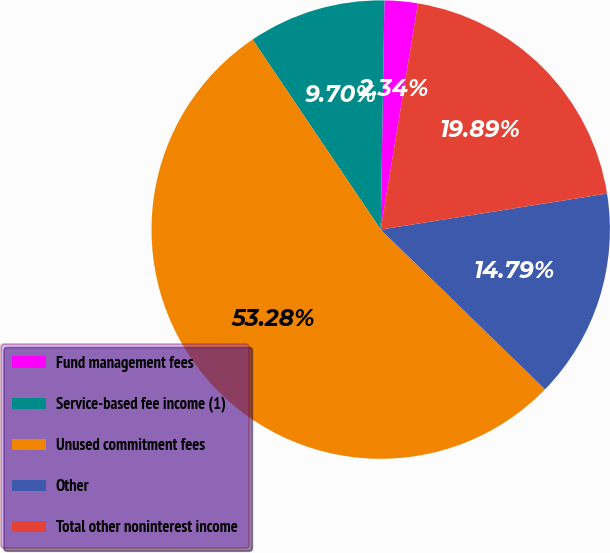Convert chart. <chart><loc_0><loc_0><loc_500><loc_500><pie_chart><fcel>Fund management fees<fcel>Service-based fee income (1)<fcel>Unused commitment fees<fcel>Other<fcel>Total other noninterest income<nl><fcel>2.34%<fcel>9.7%<fcel>53.28%<fcel>14.79%<fcel>19.89%<nl></chart> 